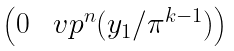Convert formula to latex. <formula><loc_0><loc_0><loc_500><loc_500>\begin{pmatrix} 0 & \ v p ^ { n } ( y _ { 1 } / \pi ^ { k - 1 } ) \end{pmatrix}</formula> 